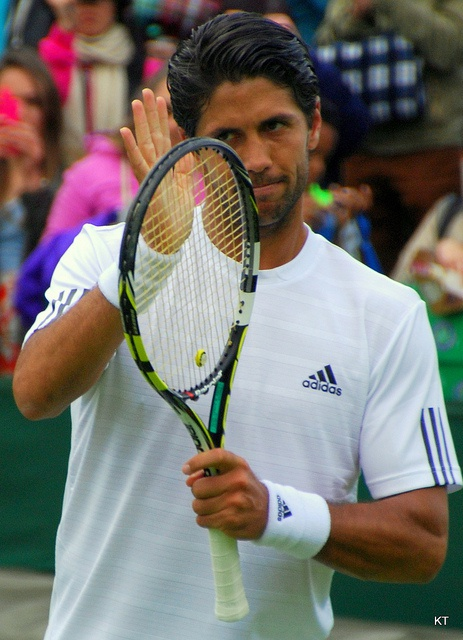Describe the objects in this image and their specific colors. I can see people in teal, lightgray, darkgray, and black tones, tennis racket in teal, lightgray, darkgray, black, and tan tones, people in teal, black, gray, tan, and brown tones, people in teal, black, gray, navy, and blue tones, and people in teal, black, maroon, and brown tones in this image. 